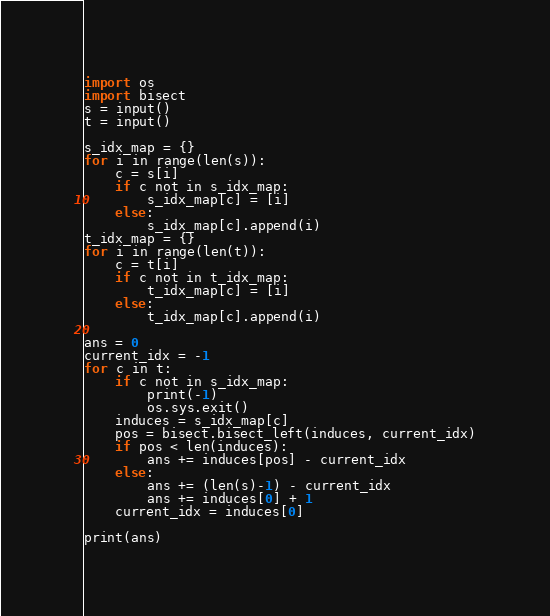<code> <loc_0><loc_0><loc_500><loc_500><_Python_>import os
import bisect
s = input()
t = input()

s_idx_map = {}
for i in range(len(s)):
    c = s[i]
    if c not in s_idx_map:
        s_idx_map[c] = [i]
    else:
        s_idx_map[c].append(i)
t_idx_map = {}
for i in range(len(t)):
    c = t[i]
    if c not in t_idx_map:
        t_idx_map[c] = [i]
    else:
        t_idx_map[c].append(i)

ans = 0
current_idx = -1
for c in t:
    if c not in s_idx_map:
        print(-1)
        os.sys.exit()
    induces = s_idx_map[c]
    pos = bisect.bisect_left(induces, current_idx)
    if pos < len(induces):
        ans += induces[pos] - current_idx
    else:
        ans += (len(s)-1) - current_idx
        ans += induces[0] + 1
    current_idx = induces[0]
    
print(ans)</code> 